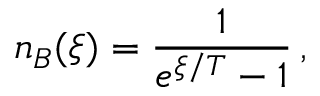Convert formula to latex. <formula><loc_0><loc_0><loc_500><loc_500>n _ { B } ( \xi ) = \frac { 1 } { e ^ { \xi / T } - 1 } \, ,</formula> 